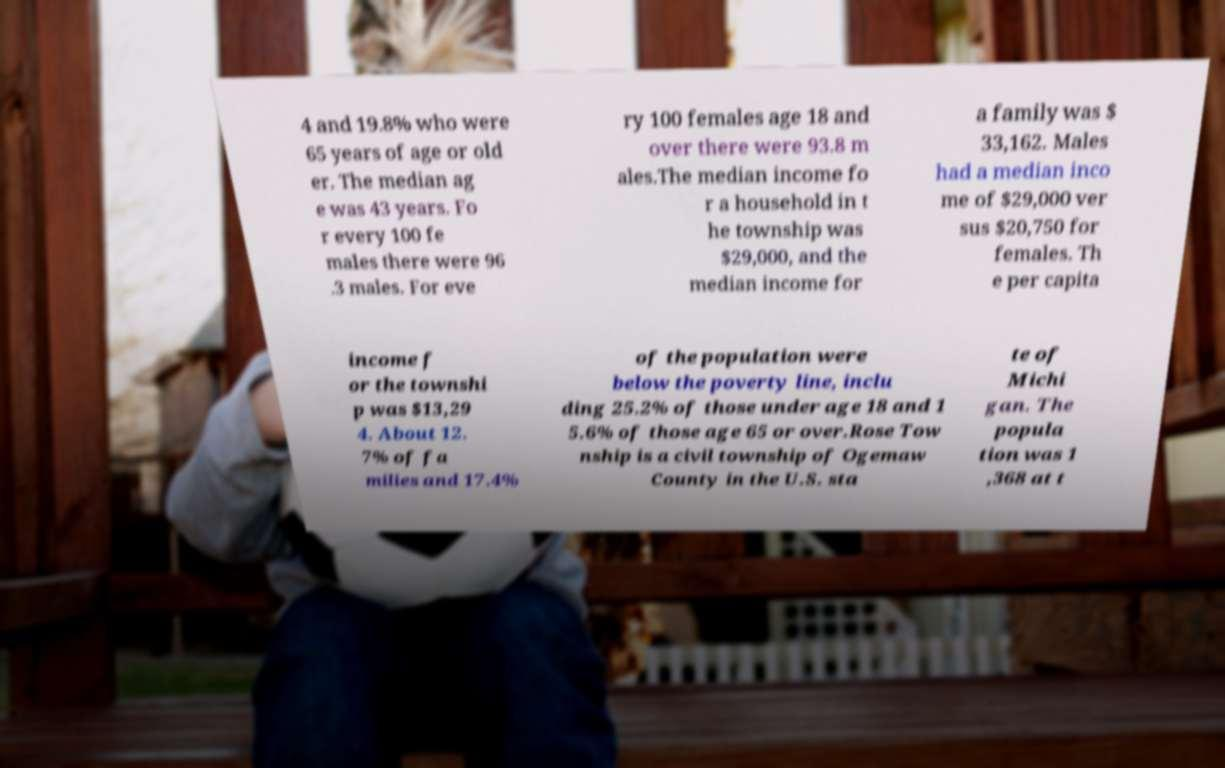Please identify and transcribe the text found in this image. 4 and 19.8% who were 65 years of age or old er. The median ag e was 43 years. Fo r every 100 fe males there were 96 .3 males. For eve ry 100 females age 18 and over there were 93.8 m ales.The median income fo r a household in t he township was $29,000, and the median income for a family was $ 33,162. Males had a median inco me of $29,000 ver sus $20,750 for females. Th e per capita income f or the townshi p was $13,29 4. About 12. 7% of fa milies and 17.4% of the population were below the poverty line, inclu ding 25.2% of those under age 18 and 1 5.6% of those age 65 or over.Rose Tow nship is a civil township of Ogemaw County in the U.S. sta te of Michi gan. The popula tion was 1 ,368 at t 